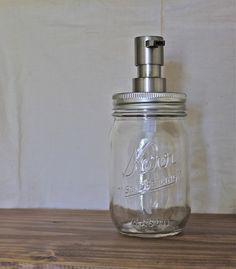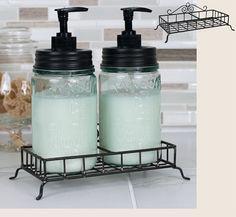The first image is the image on the left, the second image is the image on the right. Given the left and right images, does the statement "At least one bottle dispenser is facing left." hold true? Answer yes or no. No. The first image is the image on the left, the second image is the image on the right. For the images shown, is this caption "Each image shows a carrier holding two pump-top jars." true? Answer yes or no. No. 